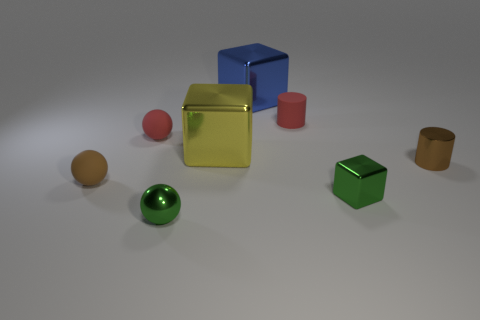Subtract all big yellow blocks. How many blocks are left? 2 Add 1 brown spheres. How many objects exist? 9 Subtract all red balls. How many balls are left? 2 Subtract 2 blocks. How many blocks are left? 1 Add 6 metallic cylinders. How many metallic cylinders exist? 7 Subtract 1 brown balls. How many objects are left? 7 Subtract all cylinders. How many objects are left? 6 Subtract all brown spheres. Subtract all brown cubes. How many spheres are left? 2 Subtract all green shiny cubes. Subtract all tiny brown cylinders. How many objects are left? 6 Add 5 tiny metal objects. How many tiny metal objects are left? 8 